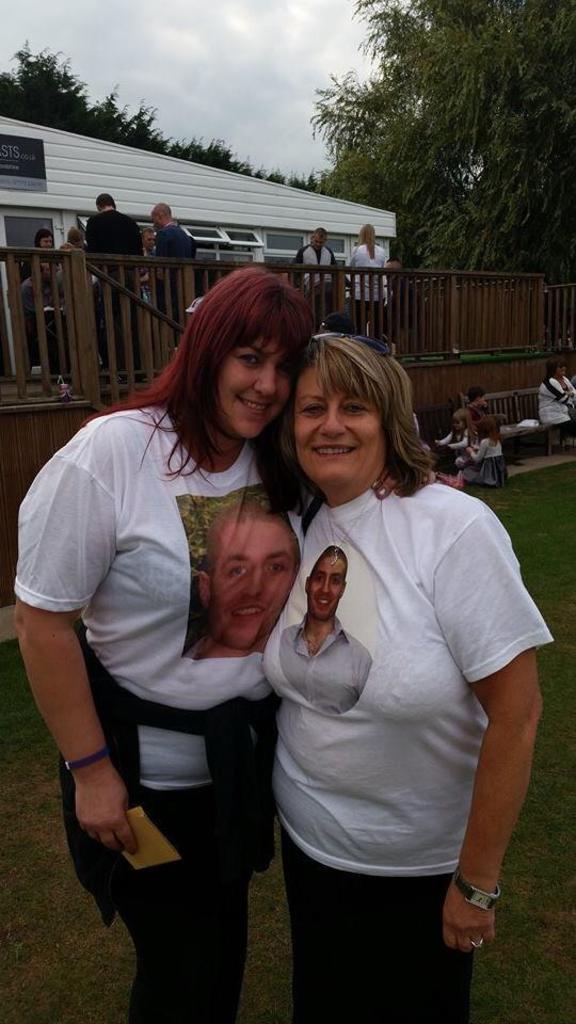Please provide a concise description of this image. In the picture I can see two women wearing white T-shirt are standing on a greenery ground and there are few people,a fence,building and trees in the background and the sky is cloudy. 